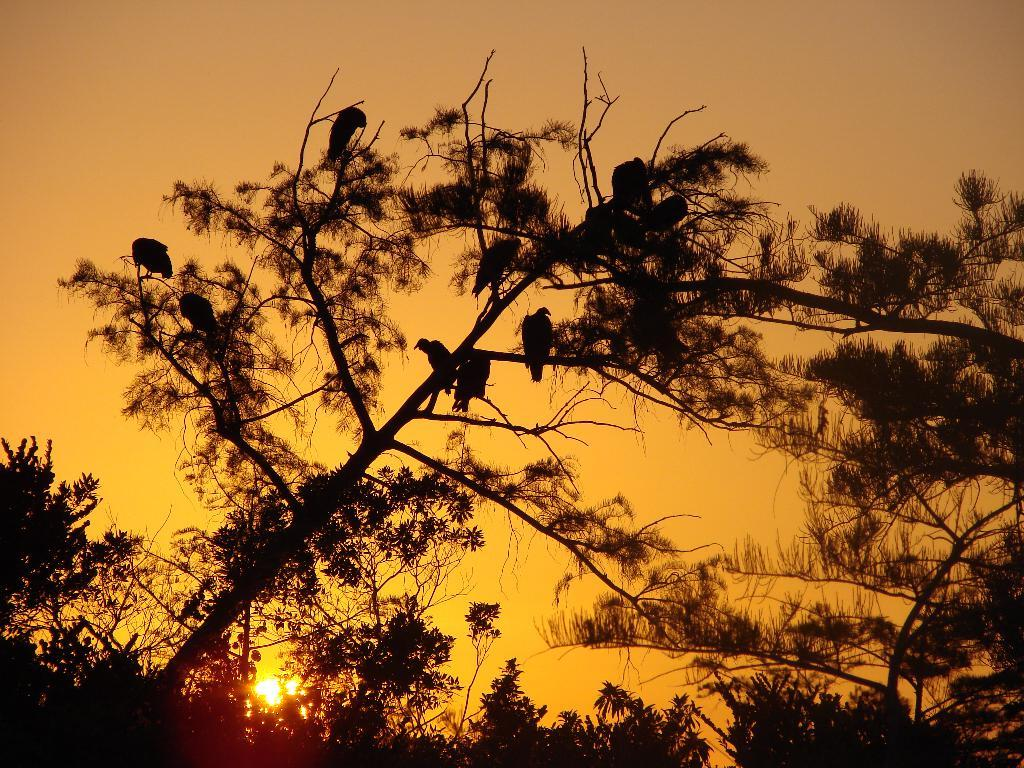What animals can be seen in the image? There are birds on a tree in the image. What type of vegetation is visible in the image? There are trees in the image. What can be seen in the background of the image? The sky is visible in the background of the image. What celestial body is observable in the sky? The sun is observable in the sky. What type of design is featured on the birds' wings in the image? There is no specific design mentioned on the birds' wings in the image; they are simply birds on a tree. 